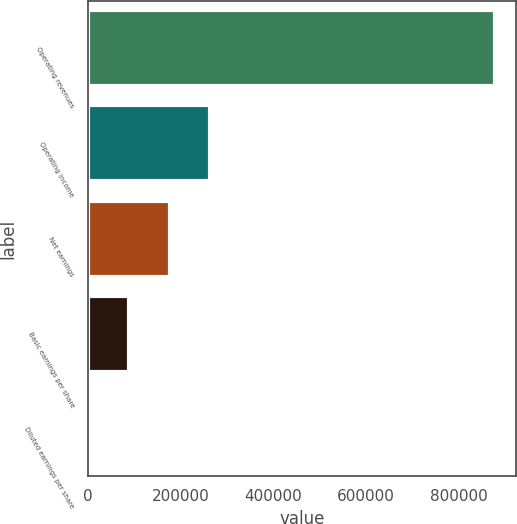Convert chart to OTSL. <chart><loc_0><loc_0><loc_500><loc_500><bar_chart><fcel>Operating revenues<fcel>Operating income<fcel>Net earnings<fcel>Basic earnings per share<fcel>Diluted earnings per share<nl><fcel>878383<fcel>263515<fcel>175677<fcel>87838.6<fcel>0.28<nl></chart> 